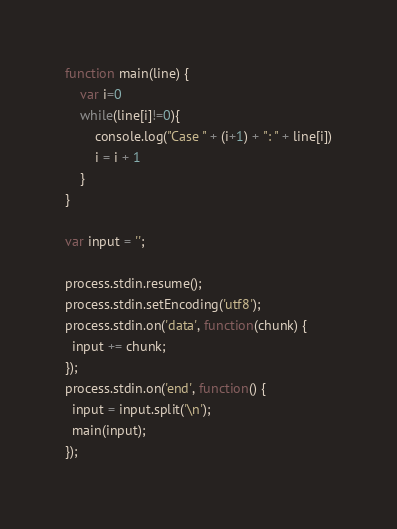Convert code to text. <code><loc_0><loc_0><loc_500><loc_500><_JavaScript_>function main(line) {
	var i=0
	while(line[i]!=0){
		console.log("Case " + (i+1) + ": " + line[i])
		i = i + 1
	}
}

var input = '';

process.stdin.resume();
process.stdin.setEncoding('utf8');
process.stdin.on('data', function(chunk) {
  input += chunk;
});
process.stdin.on('end', function() {
  input = input.split('\n');
  main(input);
});</code> 